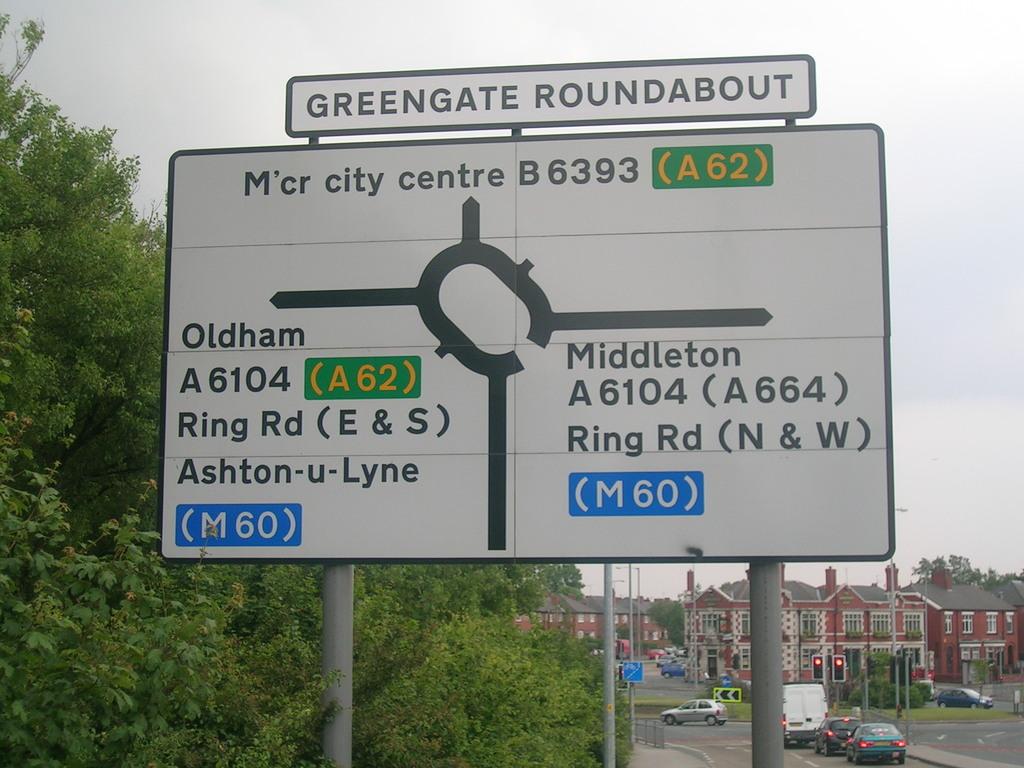What does the street sign show?
Your response must be concise. Greengate roundabout. What town starts with an o?
Provide a succinct answer. Oldham. 